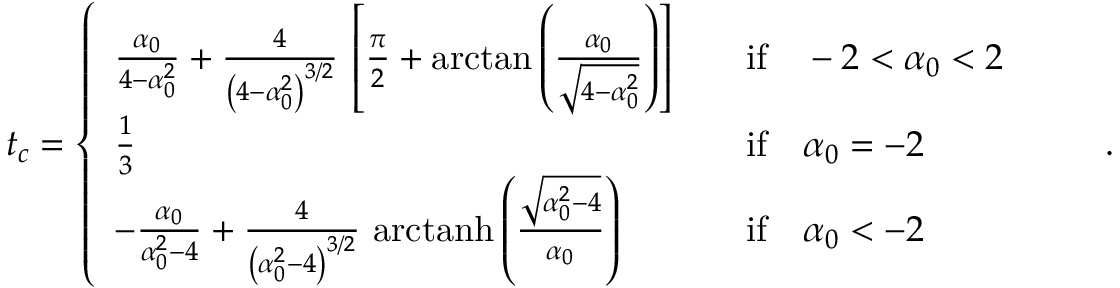<formula> <loc_0><loc_0><loc_500><loc_500>t _ { c } = \left \{ \begin{array} { l l l } { \frac { \alpha _ { 0 } } { 4 - \alpha _ { 0 } ^ { 2 } } + \frac { 4 } { \left ( 4 - \alpha _ { 0 } ^ { 2 } \right ) ^ { 3 / 2 } } \, \left [ \frac { \pi } { 2 } + \arctan \left ( \frac { \alpha _ { 0 } } { \sqrt { 4 - \alpha _ { 0 } ^ { 2 } } } \right ) \right ] } & & { i f \quad - 2 < \alpha _ { 0 } < 2 } \\ { \frac { 1 } { 3 } } & & { i f \quad \alpha _ { 0 } = - 2 } \\ { - \frac { \alpha _ { 0 } } { \alpha _ { 0 } ^ { 2 } - 4 } + \frac { 4 } { \left ( \alpha _ { 0 } ^ { 2 } - 4 \right ) ^ { 3 / 2 } } \, a r c t a n h \left ( \frac { \sqrt { \alpha _ { 0 } ^ { 2 } - 4 } } { \alpha _ { 0 } } \right ) } & & { i f \quad \alpha _ { 0 } < - 2 } \end{array} \quad .</formula> 